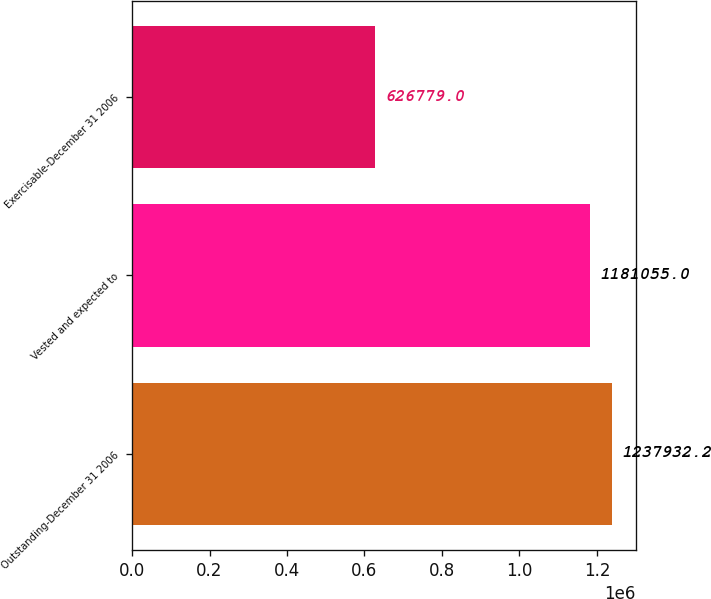Convert chart. <chart><loc_0><loc_0><loc_500><loc_500><bar_chart><fcel>Outstanding-December 31 2006<fcel>Vested and expected to<fcel>Exercisable-December 31 2006<nl><fcel>1.23793e+06<fcel>1.18106e+06<fcel>626779<nl></chart> 